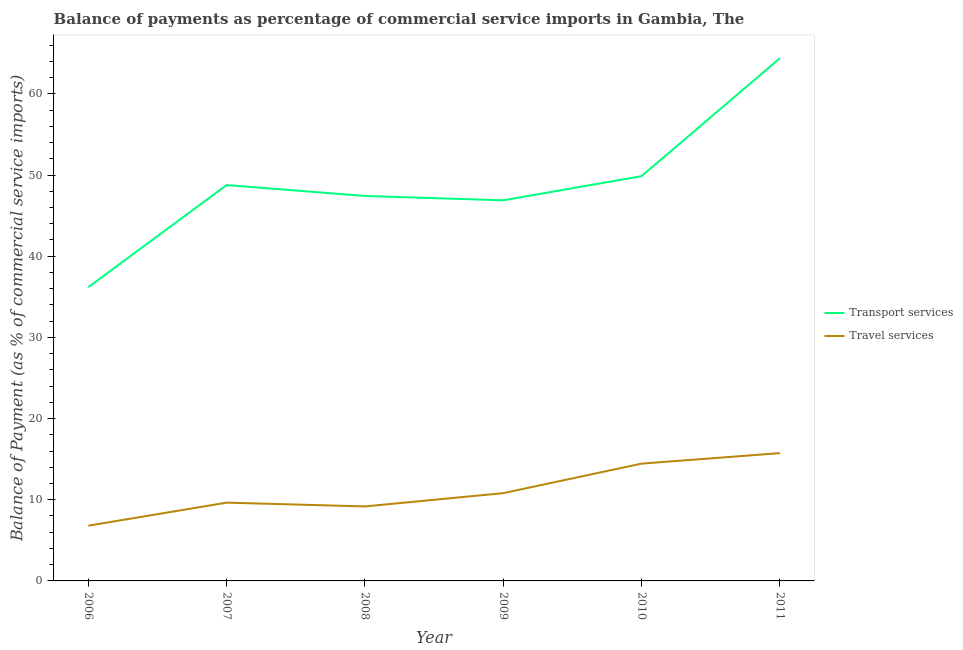How many different coloured lines are there?
Provide a short and direct response. 2. Does the line corresponding to balance of payments of transport services intersect with the line corresponding to balance of payments of travel services?
Keep it short and to the point. No. Is the number of lines equal to the number of legend labels?
Give a very brief answer. Yes. What is the balance of payments of transport services in 2006?
Your response must be concise. 36.18. Across all years, what is the maximum balance of payments of travel services?
Provide a succinct answer. 15.74. Across all years, what is the minimum balance of payments of transport services?
Your answer should be compact. 36.18. In which year was the balance of payments of transport services minimum?
Make the answer very short. 2006. What is the total balance of payments of transport services in the graph?
Make the answer very short. 293.52. What is the difference between the balance of payments of travel services in 2007 and that in 2008?
Make the answer very short. 0.47. What is the difference between the balance of payments of transport services in 2008 and the balance of payments of travel services in 2009?
Provide a succinct answer. 36.61. What is the average balance of payments of transport services per year?
Your answer should be compact. 48.92. In the year 2006, what is the difference between the balance of payments of transport services and balance of payments of travel services?
Keep it short and to the point. 29.38. In how many years, is the balance of payments of transport services greater than 40 %?
Make the answer very short. 5. What is the ratio of the balance of payments of travel services in 2007 to that in 2009?
Your answer should be compact. 0.89. Is the balance of payments of travel services in 2007 less than that in 2011?
Ensure brevity in your answer.  Yes. Is the difference between the balance of payments of transport services in 2006 and 2011 greater than the difference between the balance of payments of travel services in 2006 and 2011?
Your response must be concise. No. What is the difference between the highest and the second highest balance of payments of transport services?
Provide a succinct answer. 14.52. What is the difference between the highest and the lowest balance of payments of transport services?
Provide a succinct answer. 28.21. In how many years, is the balance of payments of transport services greater than the average balance of payments of transport services taken over all years?
Ensure brevity in your answer.  2. Is the balance of payments of transport services strictly greater than the balance of payments of travel services over the years?
Make the answer very short. Yes. Are the values on the major ticks of Y-axis written in scientific E-notation?
Provide a short and direct response. No. Does the graph contain any zero values?
Keep it short and to the point. No. Does the graph contain grids?
Provide a succinct answer. No. Where does the legend appear in the graph?
Provide a short and direct response. Center right. How are the legend labels stacked?
Provide a succinct answer. Vertical. What is the title of the graph?
Offer a terse response. Balance of payments as percentage of commercial service imports in Gambia, The. What is the label or title of the X-axis?
Make the answer very short. Year. What is the label or title of the Y-axis?
Your response must be concise. Balance of Payment (as % of commercial service imports). What is the Balance of Payment (as % of commercial service imports) of Transport services in 2006?
Offer a very short reply. 36.18. What is the Balance of Payment (as % of commercial service imports) in Travel services in 2006?
Provide a short and direct response. 6.81. What is the Balance of Payment (as % of commercial service imports) in Transport services in 2007?
Provide a succinct answer. 48.77. What is the Balance of Payment (as % of commercial service imports) in Travel services in 2007?
Make the answer very short. 9.64. What is the Balance of Payment (as % of commercial service imports) in Transport services in 2008?
Provide a succinct answer. 47.43. What is the Balance of Payment (as % of commercial service imports) of Travel services in 2008?
Provide a succinct answer. 9.18. What is the Balance of Payment (as % of commercial service imports) of Transport services in 2009?
Keep it short and to the point. 46.89. What is the Balance of Payment (as % of commercial service imports) in Travel services in 2009?
Your answer should be compact. 10.81. What is the Balance of Payment (as % of commercial service imports) of Transport services in 2010?
Provide a succinct answer. 49.87. What is the Balance of Payment (as % of commercial service imports) of Travel services in 2010?
Ensure brevity in your answer.  14.45. What is the Balance of Payment (as % of commercial service imports) of Transport services in 2011?
Keep it short and to the point. 64.39. What is the Balance of Payment (as % of commercial service imports) of Travel services in 2011?
Keep it short and to the point. 15.74. Across all years, what is the maximum Balance of Payment (as % of commercial service imports) in Transport services?
Provide a short and direct response. 64.39. Across all years, what is the maximum Balance of Payment (as % of commercial service imports) of Travel services?
Ensure brevity in your answer.  15.74. Across all years, what is the minimum Balance of Payment (as % of commercial service imports) in Transport services?
Provide a succinct answer. 36.18. Across all years, what is the minimum Balance of Payment (as % of commercial service imports) in Travel services?
Your answer should be compact. 6.81. What is the total Balance of Payment (as % of commercial service imports) of Transport services in the graph?
Give a very brief answer. 293.52. What is the total Balance of Payment (as % of commercial service imports) of Travel services in the graph?
Your answer should be compact. 66.64. What is the difference between the Balance of Payment (as % of commercial service imports) in Transport services in 2006 and that in 2007?
Your answer should be very brief. -12.58. What is the difference between the Balance of Payment (as % of commercial service imports) of Travel services in 2006 and that in 2007?
Your response must be concise. -2.84. What is the difference between the Balance of Payment (as % of commercial service imports) in Transport services in 2006 and that in 2008?
Offer a terse response. -11.24. What is the difference between the Balance of Payment (as % of commercial service imports) of Travel services in 2006 and that in 2008?
Provide a succinct answer. -2.37. What is the difference between the Balance of Payment (as % of commercial service imports) of Transport services in 2006 and that in 2009?
Provide a short and direct response. -10.71. What is the difference between the Balance of Payment (as % of commercial service imports) in Travel services in 2006 and that in 2009?
Offer a very short reply. -4.01. What is the difference between the Balance of Payment (as % of commercial service imports) in Transport services in 2006 and that in 2010?
Your answer should be compact. -13.68. What is the difference between the Balance of Payment (as % of commercial service imports) of Travel services in 2006 and that in 2010?
Ensure brevity in your answer.  -7.64. What is the difference between the Balance of Payment (as % of commercial service imports) of Transport services in 2006 and that in 2011?
Ensure brevity in your answer.  -28.21. What is the difference between the Balance of Payment (as % of commercial service imports) in Travel services in 2006 and that in 2011?
Give a very brief answer. -8.94. What is the difference between the Balance of Payment (as % of commercial service imports) of Transport services in 2007 and that in 2008?
Your answer should be compact. 1.34. What is the difference between the Balance of Payment (as % of commercial service imports) in Travel services in 2007 and that in 2008?
Offer a terse response. 0.47. What is the difference between the Balance of Payment (as % of commercial service imports) in Transport services in 2007 and that in 2009?
Provide a succinct answer. 1.88. What is the difference between the Balance of Payment (as % of commercial service imports) in Travel services in 2007 and that in 2009?
Keep it short and to the point. -1.17. What is the difference between the Balance of Payment (as % of commercial service imports) of Transport services in 2007 and that in 2010?
Ensure brevity in your answer.  -1.1. What is the difference between the Balance of Payment (as % of commercial service imports) of Travel services in 2007 and that in 2010?
Your answer should be very brief. -4.81. What is the difference between the Balance of Payment (as % of commercial service imports) in Transport services in 2007 and that in 2011?
Keep it short and to the point. -15.62. What is the difference between the Balance of Payment (as % of commercial service imports) in Travel services in 2007 and that in 2011?
Your answer should be very brief. -6.1. What is the difference between the Balance of Payment (as % of commercial service imports) in Transport services in 2008 and that in 2009?
Offer a very short reply. 0.54. What is the difference between the Balance of Payment (as % of commercial service imports) in Travel services in 2008 and that in 2009?
Provide a succinct answer. -1.64. What is the difference between the Balance of Payment (as % of commercial service imports) in Transport services in 2008 and that in 2010?
Ensure brevity in your answer.  -2.44. What is the difference between the Balance of Payment (as % of commercial service imports) of Travel services in 2008 and that in 2010?
Your response must be concise. -5.27. What is the difference between the Balance of Payment (as % of commercial service imports) of Transport services in 2008 and that in 2011?
Your response must be concise. -16.96. What is the difference between the Balance of Payment (as % of commercial service imports) of Travel services in 2008 and that in 2011?
Your response must be concise. -6.57. What is the difference between the Balance of Payment (as % of commercial service imports) of Transport services in 2009 and that in 2010?
Offer a terse response. -2.98. What is the difference between the Balance of Payment (as % of commercial service imports) of Travel services in 2009 and that in 2010?
Offer a very short reply. -3.64. What is the difference between the Balance of Payment (as % of commercial service imports) in Transport services in 2009 and that in 2011?
Make the answer very short. -17.5. What is the difference between the Balance of Payment (as % of commercial service imports) of Travel services in 2009 and that in 2011?
Give a very brief answer. -4.93. What is the difference between the Balance of Payment (as % of commercial service imports) of Transport services in 2010 and that in 2011?
Offer a terse response. -14.52. What is the difference between the Balance of Payment (as % of commercial service imports) of Travel services in 2010 and that in 2011?
Ensure brevity in your answer.  -1.29. What is the difference between the Balance of Payment (as % of commercial service imports) of Transport services in 2006 and the Balance of Payment (as % of commercial service imports) of Travel services in 2007?
Your response must be concise. 26.54. What is the difference between the Balance of Payment (as % of commercial service imports) of Transport services in 2006 and the Balance of Payment (as % of commercial service imports) of Travel services in 2008?
Provide a succinct answer. 27.01. What is the difference between the Balance of Payment (as % of commercial service imports) in Transport services in 2006 and the Balance of Payment (as % of commercial service imports) in Travel services in 2009?
Provide a succinct answer. 25.37. What is the difference between the Balance of Payment (as % of commercial service imports) of Transport services in 2006 and the Balance of Payment (as % of commercial service imports) of Travel services in 2010?
Your response must be concise. 21.73. What is the difference between the Balance of Payment (as % of commercial service imports) in Transport services in 2006 and the Balance of Payment (as % of commercial service imports) in Travel services in 2011?
Provide a short and direct response. 20.44. What is the difference between the Balance of Payment (as % of commercial service imports) in Transport services in 2007 and the Balance of Payment (as % of commercial service imports) in Travel services in 2008?
Provide a succinct answer. 39.59. What is the difference between the Balance of Payment (as % of commercial service imports) of Transport services in 2007 and the Balance of Payment (as % of commercial service imports) of Travel services in 2009?
Offer a very short reply. 37.95. What is the difference between the Balance of Payment (as % of commercial service imports) of Transport services in 2007 and the Balance of Payment (as % of commercial service imports) of Travel services in 2010?
Your answer should be compact. 34.32. What is the difference between the Balance of Payment (as % of commercial service imports) of Transport services in 2007 and the Balance of Payment (as % of commercial service imports) of Travel services in 2011?
Keep it short and to the point. 33.02. What is the difference between the Balance of Payment (as % of commercial service imports) in Transport services in 2008 and the Balance of Payment (as % of commercial service imports) in Travel services in 2009?
Offer a terse response. 36.61. What is the difference between the Balance of Payment (as % of commercial service imports) of Transport services in 2008 and the Balance of Payment (as % of commercial service imports) of Travel services in 2010?
Your answer should be compact. 32.97. What is the difference between the Balance of Payment (as % of commercial service imports) in Transport services in 2008 and the Balance of Payment (as % of commercial service imports) in Travel services in 2011?
Offer a very short reply. 31.68. What is the difference between the Balance of Payment (as % of commercial service imports) in Transport services in 2009 and the Balance of Payment (as % of commercial service imports) in Travel services in 2010?
Provide a succinct answer. 32.44. What is the difference between the Balance of Payment (as % of commercial service imports) in Transport services in 2009 and the Balance of Payment (as % of commercial service imports) in Travel services in 2011?
Your response must be concise. 31.15. What is the difference between the Balance of Payment (as % of commercial service imports) in Transport services in 2010 and the Balance of Payment (as % of commercial service imports) in Travel services in 2011?
Your answer should be compact. 34.12. What is the average Balance of Payment (as % of commercial service imports) of Transport services per year?
Keep it short and to the point. 48.92. What is the average Balance of Payment (as % of commercial service imports) in Travel services per year?
Keep it short and to the point. 11.11. In the year 2006, what is the difference between the Balance of Payment (as % of commercial service imports) of Transport services and Balance of Payment (as % of commercial service imports) of Travel services?
Ensure brevity in your answer.  29.38. In the year 2007, what is the difference between the Balance of Payment (as % of commercial service imports) of Transport services and Balance of Payment (as % of commercial service imports) of Travel services?
Your answer should be compact. 39.12. In the year 2008, what is the difference between the Balance of Payment (as % of commercial service imports) of Transport services and Balance of Payment (as % of commercial service imports) of Travel services?
Offer a very short reply. 38.25. In the year 2009, what is the difference between the Balance of Payment (as % of commercial service imports) of Transport services and Balance of Payment (as % of commercial service imports) of Travel services?
Ensure brevity in your answer.  36.08. In the year 2010, what is the difference between the Balance of Payment (as % of commercial service imports) of Transport services and Balance of Payment (as % of commercial service imports) of Travel services?
Provide a short and direct response. 35.41. In the year 2011, what is the difference between the Balance of Payment (as % of commercial service imports) in Transport services and Balance of Payment (as % of commercial service imports) in Travel services?
Offer a very short reply. 48.65. What is the ratio of the Balance of Payment (as % of commercial service imports) in Transport services in 2006 to that in 2007?
Ensure brevity in your answer.  0.74. What is the ratio of the Balance of Payment (as % of commercial service imports) of Travel services in 2006 to that in 2007?
Provide a succinct answer. 0.71. What is the ratio of the Balance of Payment (as % of commercial service imports) in Transport services in 2006 to that in 2008?
Your answer should be very brief. 0.76. What is the ratio of the Balance of Payment (as % of commercial service imports) of Travel services in 2006 to that in 2008?
Provide a succinct answer. 0.74. What is the ratio of the Balance of Payment (as % of commercial service imports) of Transport services in 2006 to that in 2009?
Your answer should be very brief. 0.77. What is the ratio of the Balance of Payment (as % of commercial service imports) in Travel services in 2006 to that in 2009?
Your answer should be compact. 0.63. What is the ratio of the Balance of Payment (as % of commercial service imports) of Transport services in 2006 to that in 2010?
Provide a short and direct response. 0.73. What is the ratio of the Balance of Payment (as % of commercial service imports) in Travel services in 2006 to that in 2010?
Provide a short and direct response. 0.47. What is the ratio of the Balance of Payment (as % of commercial service imports) in Transport services in 2006 to that in 2011?
Your answer should be very brief. 0.56. What is the ratio of the Balance of Payment (as % of commercial service imports) of Travel services in 2006 to that in 2011?
Your answer should be compact. 0.43. What is the ratio of the Balance of Payment (as % of commercial service imports) in Transport services in 2007 to that in 2008?
Provide a short and direct response. 1.03. What is the ratio of the Balance of Payment (as % of commercial service imports) in Travel services in 2007 to that in 2008?
Provide a short and direct response. 1.05. What is the ratio of the Balance of Payment (as % of commercial service imports) of Transport services in 2007 to that in 2009?
Your response must be concise. 1.04. What is the ratio of the Balance of Payment (as % of commercial service imports) in Travel services in 2007 to that in 2009?
Your answer should be very brief. 0.89. What is the ratio of the Balance of Payment (as % of commercial service imports) in Transport services in 2007 to that in 2010?
Ensure brevity in your answer.  0.98. What is the ratio of the Balance of Payment (as % of commercial service imports) in Travel services in 2007 to that in 2010?
Your answer should be compact. 0.67. What is the ratio of the Balance of Payment (as % of commercial service imports) of Transport services in 2007 to that in 2011?
Keep it short and to the point. 0.76. What is the ratio of the Balance of Payment (as % of commercial service imports) of Travel services in 2007 to that in 2011?
Ensure brevity in your answer.  0.61. What is the ratio of the Balance of Payment (as % of commercial service imports) of Transport services in 2008 to that in 2009?
Provide a short and direct response. 1.01. What is the ratio of the Balance of Payment (as % of commercial service imports) in Travel services in 2008 to that in 2009?
Give a very brief answer. 0.85. What is the ratio of the Balance of Payment (as % of commercial service imports) of Transport services in 2008 to that in 2010?
Provide a short and direct response. 0.95. What is the ratio of the Balance of Payment (as % of commercial service imports) in Travel services in 2008 to that in 2010?
Provide a short and direct response. 0.64. What is the ratio of the Balance of Payment (as % of commercial service imports) in Transport services in 2008 to that in 2011?
Your answer should be compact. 0.74. What is the ratio of the Balance of Payment (as % of commercial service imports) of Travel services in 2008 to that in 2011?
Make the answer very short. 0.58. What is the ratio of the Balance of Payment (as % of commercial service imports) in Transport services in 2009 to that in 2010?
Ensure brevity in your answer.  0.94. What is the ratio of the Balance of Payment (as % of commercial service imports) of Travel services in 2009 to that in 2010?
Give a very brief answer. 0.75. What is the ratio of the Balance of Payment (as % of commercial service imports) in Transport services in 2009 to that in 2011?
Your response must be concise. 0.73. What is the ratio of the Balance of Payment (as % of commercial service imports) in Travel services in 2009 to that in 2011?
Your answer should be very brief. 0.69. What is the ratio of the Balance of Payment (as % of commercial service imports) of Transport services in 2010 to that in 2011?
Provide a succinct answer. 0.77. What is the ratio of the Balance of Payment (as % of commercial service imports) in Travel services in 2010 to that in 2011?
Your response must be concise. 0.92. What is the difference between the highest and the second highest Balance of Payment (as % of commercial service imports) in Transport services?
Your answer should be very brief. 14.52. What is the difference between the highest and the second highest Balance of Payment (as % of commercial service imports) in Travel services?
Offer a very short reply. 1.29. What is the difference between the highest and the lowest Balance of Payment (as % of commercial service imports) of Transport services?
Ensure brevity in your answer.  28.21. What is the difference between the highest and the lowest Balance of Payment (as % of commercial service imports) in Travel services?
Your answer should be compact. 8.94. 